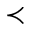Convert formula to latex. <formula><loc_0><loc_0><loc_500><loc_500>\prec</formula> 